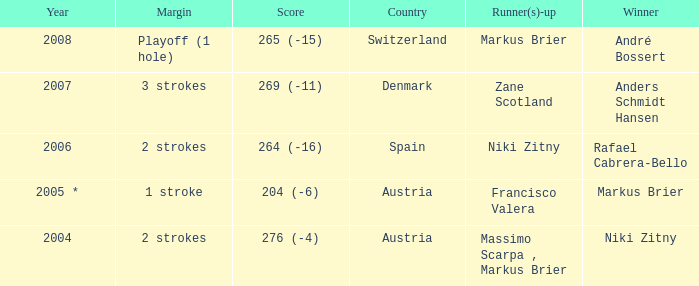Who was the runner-up when the margin was 1 stroke? Francisco Valera. 